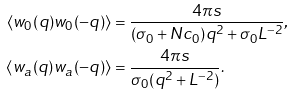<formula> <loc_0><loc_0><loc_500><loc_500>\langle w _ { 0 } ( q ) w _ { 0 } ( - q ) \rangle & = \frac { 4 \pi s } { ( \sigma _ { 0 } + N c _ { 0 } ) q ^ { 2 } + \sigma _ { 0 } L ^ { - 2 } } , \\ \langle w _ { a } ( q ) w _ { a } ( - q ) \rangle & = \frac { 4 \pi s } { \sigma _ { 0 } ( q ^ { 2 } + L ^ { - 2 } ) } .</formula> 